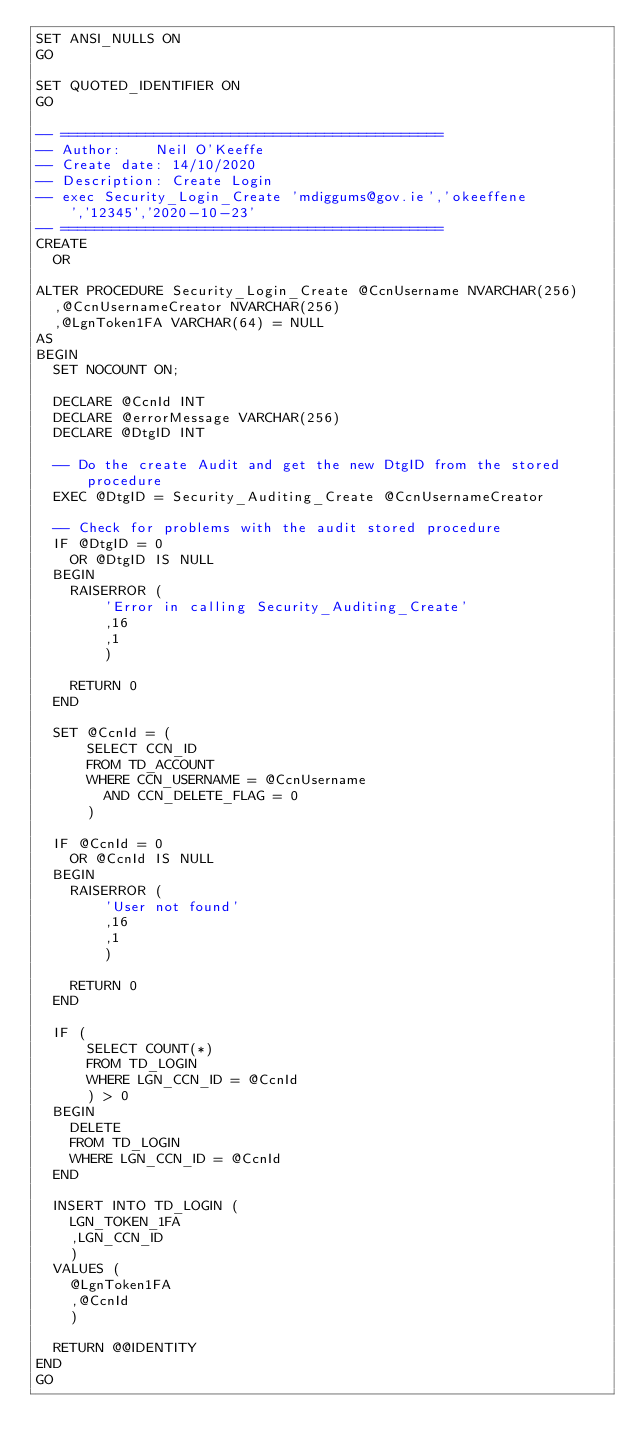Convert code to text. <code><loc_0><loc_0><loc_500><loc_500><_SQL_>SET ANSI_NULLS ON
GO

SET QUOTED_IDENTIFIER ON
GO

-- =============================================
-- Author:		Neil O'Keeffe
-- Create date: 14/10/2020
-- Description:	Create Login
-- exec Security_Login_Create 'mdiggums@gov.ie','okeeffene','12345','2020-10-23'
-- =============================================
CREATE
	OR

ALTER PROCEDURE Security_Login_Create @CcnUsername NVARCHAR(256)
	,@CcnUsernameCreator NVARCHAR(256)
	,@LgnToken1FA VARCHAR(64) = NULL
AS
BEGIN
	SET NOCOUNT ON;

	DECLARE @CcnId INT
	DECLARE @errorMessage VARCHAR(256)
	DECLARE @DtgID INT

	-- Do the create Audit and get the new DtgID from the stored procedure
	EXEC @DtgID = Security_Auditing_Create @CcnUsernameCreator

	-- Check for problems with the audit stored procedure
	IF @DtgID = 0
		OR @DtgID IS NULL
	BEGIN
		RAISERROR (
				'Error in calling Security_Auditing_Create'
				,16
				,1
				)

		RETURN 0
	END

	SET @CcnId = (
			SELECT CCN_ID
			FROM TD_ACCOUNT
			WHERE CCN_USERNAME = @CcnUsername
				AND CCN_DELETE_FLAG = 0
			)

	IF @CcnId = 0
		OR @CcnId IS NULL
	BEGIN
		RAISERROR (
				'User not found'
				,16
				,1
				)

		RETURN 0
	END

	IF (
			SELECT COUNT(*)
			FROM TD_LOGIN
			WHERE LGN_CCN_ID = @CcnId
			) > 0
	BEGIN
		DELETE
		FROM TD_LOGIN
		WHERE LGN_CCN_ID = @CcnId
	END

	INSERT INTO TD_LOGIN (
		LGN_TOKEN_1FA
		,LGN_CCN_ID
		)
	VALUES (
		@LgnToken1FA
		,@CcnId
		)

	RETURN @@IDENTITY
END
GO


</code> 